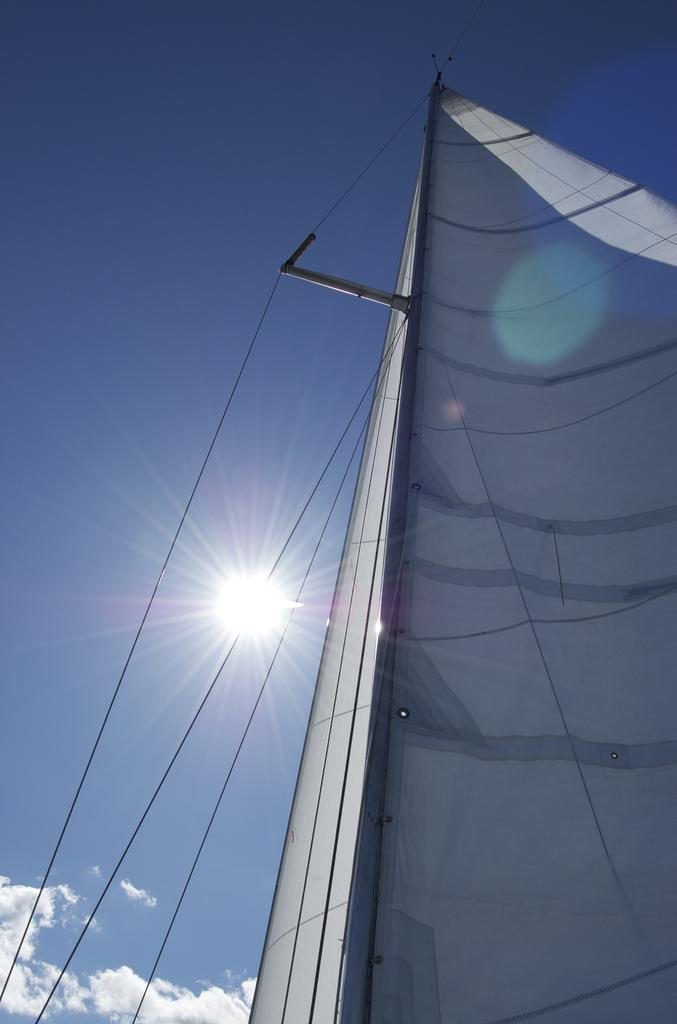What can be seen on the left side of the image? There are wires on the left side of the image. What is located on the right side of the image? There is a white-colored object on the right side of the image. What is visible in the background of the image? Clouds and the sky are visible in the background of the image. Can the sun be seen in the image? Yes, the sun is observable in the sky. How does the white-colored object on the right side of the image sort the clouds in the background? The white-colored object does not sort the clouds in the background; it is a separate object in the image. What type of science experiment is being conducted in the image? There is no indication of a science experiment being conducted in the image. 